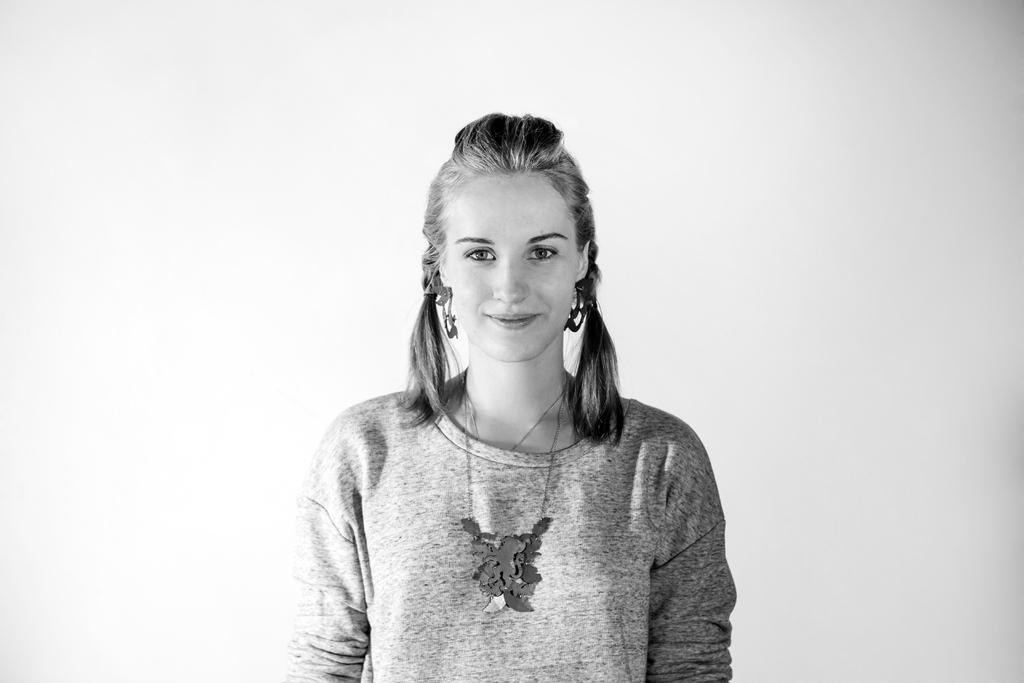Who is present in the image? There is a woman in the image. What expression does the woman have? The woman is smiling. What is the color scheme of the image? The image is in black and white. What type of texture can be seen on the woman's clothing in the image? The image is in black and white, so it is not possible to determine the texture of the woman's clothing. 